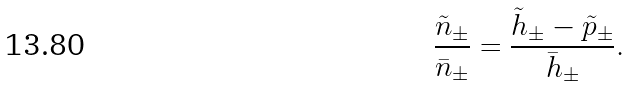Convert formula to latex. <formula><loc_0><loc_0><loc_500><loc_500>\frac { \tilde { n } _ { \pm } } { \bar { n } _ { \pm } } = \frac { \tilde { h } _ { \pm } - \tilde { p } _ { \pm } } { \bar { h } _ { \pm } } .</formula> 